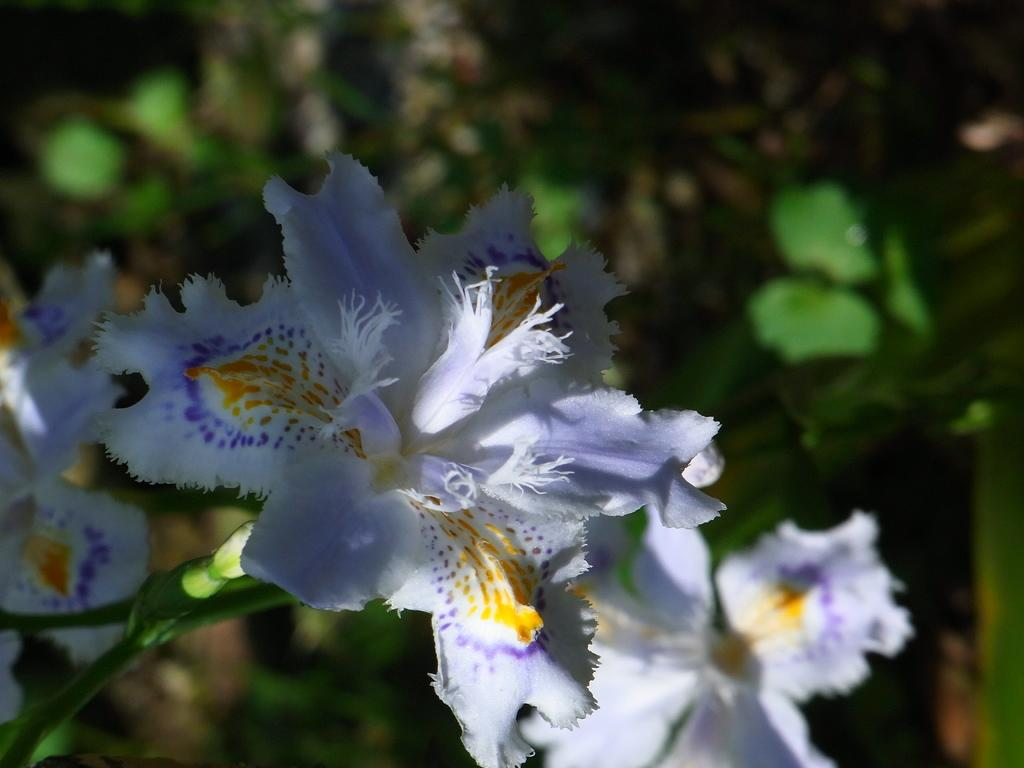What type of plants can be seen in the image? There are flowers in the image. What part of the flowers is visible in the image? There are stems in the image. Can you describe the background of the image? The background of the image is not in focus. What is the current rate of the cow in the market? There is no cow present in the image, so it is not possible to determine the current rate of a cow in the market. 